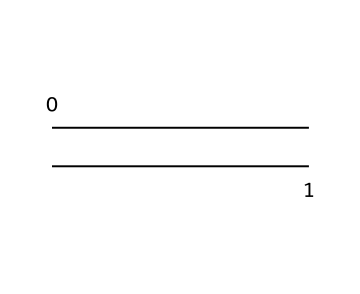What is the name of the hydrocarbon represented by this structure? The structure consists of two carbon atoms connected by a double bond, which corresponds to ethylene, a simple alkene.
Answer: ethylene How many hydrogen atoms are attached to the carbon atoms in this structure? Each carbon in ethylene is bonded to two hydrogen atoms, resulting in a total of four hydrogen atoms (two per carbon).
Answer: four What type of bond exists between the carbon atoms in ethylene? The structure shows a double bond between the two carbon atoms, as indicated by the connection that includes two pairs of shared electrons.
Answer: double bond What is the molecular geometry around the carbon atoms in ethylene? The carbon atoms are arranged in a planar configuration, which is typical for compounds with a double bond, leading to a trigonal planar geometry around each carbon.
Answer: trigonal planar How does ethylene contribute to the production of polymers? Ethylene can undergo polymerization, where the double bond between carbon atoms can open up to form long chains, resulting in polymer products like polyethylene.
Answer: polymerization What physical state is ethylene typically found in at room temperature? Ethylene is a gaseous hydrocarbon at room temperature and standard atmospheric pressure.
Answer: gas 